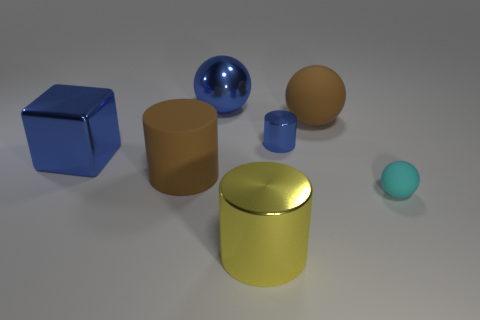Subtract all big balls. How many balls are left? 1 Add 2 blue balls. How many objects exist? 9 Subtract all green spheres. Subtract all purple cylinders. How many spheres are left? 3 Subtract all cubes. How many objects are left? 6 Subtract all large yellow metal objects. Subtract all blue blocks. How many objects are left? 5 Add 2 large rubber balls. How many large rubber balls are left? 3 Add 6 large gray metal things. How many large gray metal things exist? 6 Subtract 0 purple balls. How many objects are left? 7 